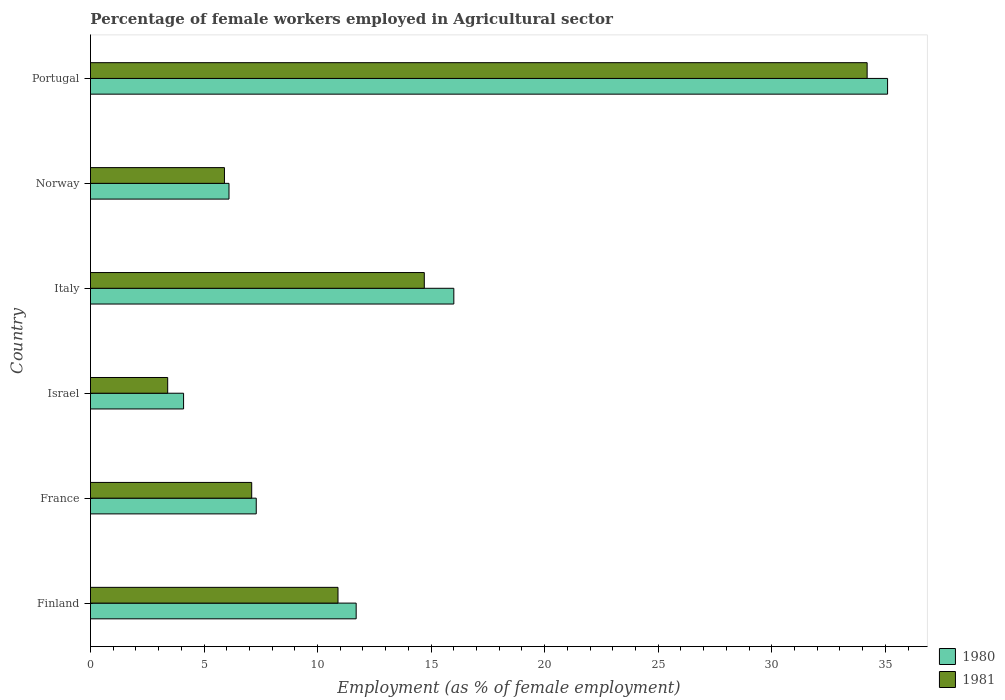Are the number of bars per tick equal to the number of legend labels?
Make the answer very short. Yes. How many bars are there on the 5th tick from the top?
Your answer should be very brief. 2. What is the label of the 4th group of bars from the top?
Make the answer very short. Israel. What is the percentage of females employed in Agricultural sector in 1981 in Norway?
Your response must be concise. 5.9. Across all countries, what is the maximum percentage of females employed in Agricultural sector in 1980?
Provide a short and direct response. 35.1. Across all countries, what is the minimum percentage of females employed in Agricultural sector in 1980?
Offer a terse response. 4.1. In which country was the percentage of females employed in Agricultural sector in 1980 maximum?
Offer a very short reply. Portugal. What is the total percentage of females employed in Agricultural sector in 1981 in the graph?
Provide a short and direct response. 76.2. What is the difference between the percentage of females employed in Agricultural sector in 1980 in Italy and that in Portugal?
Offer a terse response. -19.1. What is the difference between the percentage of females employed in Agricultural sector in 1981 in Israel and the percentage of females employed in Agricultural sector in 1980 in Norway?
Offer a very short reply. -2.7. What is the average percentage of females employed in Agricultural sector in 1981 per country?
Give a very brief answer. 12.7. What is the difference between the percentage of females employed in Agricultural sector in 1981 and percentage of females employed in Agricultural sector in 1980 in Italy?
Provide a succinct answer. -1.3. In how many countries, is the percentage of females employed in Agricultural sector in 1981 greater than 30 %?
Make the answer very short. 1. What is the ratio of the percentage of females employed in Agricultural sector in 1981 in Finland to that in Norway?
Provide a short and direct response. 1.85. Is the percentage of females employed in Agricultural sector in 1981 in France less than that in Portugal?
Your response must be concise. Yes. What is the difference between the highest and the second highest percentage of females employed in Agricultural sector in 1980?
Make the answer very short. 19.1. What is the difference between the highest and the lowest percentage of females employed in Agricultural sector in 1981?
Keep it short and to the point. 30.8. What does the 2nd bar from the top in Italy represents?
Provide a short and direct response. 1980. What does the 2nd bar from the bottom in Italy represents?
Ensure brevity in your answer.  1981. Are all the bars in the graph horizontal?
Offer a very short reply. Yes. What is the difference between two consecutive major ticks on the X-axis?
Provide a succinct answer. 5. Does the graph contain any zero values?
Provide a succinct answer. No. Does the graph contain grids?
Ensure brevity in your answer.  No. Where does the legend appear in the graph?
Your response must be concise. Bottom right. What is the title of the graph?
Offer a very short reply. Percentage of female workers employed in Agricultural sector. What is the label or title of the X-axis?
Make the answer very short. Employment (as % of female employment). What is the label or title of the Y-axis?
Provide a succinct answer. Country. What is the Employment (as % of female employment) of 1980 in Finland?
Ensure brevity in your answer.  11.7. What is the Employment (as % of female employment) in 1981 in Finland?
Provide a short and direct response. 10.9. What is the Employment (as % of female employment) in 1980 in France?
Offer a terse response. 7.3. What is the Employment (as % of female employment) in 1981 in France?
Your answer should be very brief. 7.1. What is the Employment (as % of female employment) of 1980 in Israel?
Offer a terse response. 4.1. What is the Employment (as % of female employment) in 1981 in Israel?
Give a very brief answer. 3.4. What is the Employment (as % of female employment) in 1980 in Italy?
Keep it short and to the point. 16. What is the Employment (as % of female employment) of 1981 in Italy?
Your answer should be compact. 14.7. What is the Employment (as % of female employment) in 1980 in Norway?
Make the answer very short. 6.1. What is the Employment (as % of female employment) in 1981 in Norway?
Your answer should be very brief. 5.9. What is the Employment (as % of female employment) in 1980 in Portugal?
Provide a succinct answer. 35.1. What is the Employment (as % of female employment) of 1981 in Portugal?
Provide a short and direct response. 34.2. Across all countries, what is the maximum Employment (as % of female employment) of 1980?
Your answer should be very brief. 35.1. Across all countries, what is the maximum Employment (as % of female employment) of 1981?
Provide a short and direct response. 34.2. Across all countries, what is the minimum Employment (as % of female employment) of 1980?
Provide a short and direct response. 4.1. Across all countries, what is the minimum Employment (as % of female employment) of 1981?
Offer a terse response. 3.4. What is the total Employment (as % of female employment) in 1980 in the graph?
Give a very brief answer. 80.3. What is the total Employment (as % of female employment) in 1981 in the graph?
Offer a terse response. 76.2. What is the difference between the Employment (as % of female employment) of 1980 in Finland and that in France?
Your answer should be compact. 4.4. What is the difference between the Employment (as % of female employment) in 1981 in Finland and that in Israel?
Offer a terse response. 7.5. What is the difference between the Employment (as % of female employment) of 1980 in Finland and that in Italy?
Offer a terse response. -4.3. What is the difference between the Employment (as % of female employment) of 1980 in Finland and that in Norway?
Your answer should be very brief. 5.6. What is the difference between the Employment (as % of female employment) of 1981 in Finland and that in Norway?
Make the answer very short. 5. What is the difference between the Employment (as % of female employment) of 1980 in Finland and that in Portugal?
Provide a succinct answer. -23.4. What is the difference between the Employment (as % of female employment) in 1981 in Finland and that in Portugal?
Offer a very short reply. -23.3. What is the difference between the Employment (as % of female employment) of 1981 in France and that in Israel?
Provide a short and direct response. 3.7. What is the difference between the Employment (as % of female employment) of 1980 in France and that in Italy?
Ensure brevity in your answer.  -8.7. What is the difference between the Employment (as % of female employment) in 1981 in France and that in Italy?
Keep it short and to the point. -7.6. What is the difference between the Employment (as % of female employment) in 1980 in France and that in Norway?
Offer a terse response. 1.2. What is the difference between the Employment (as % of female employment) in 1981 in France and that in Norway?
Your answer should be compact. 1.2. What is the difference between the Employment (as % of female employment) of 1980 in France and that in Portugal?
Your answer should be very brief. -27.8. What is the difference between the Employment (as % of female employment) in 1981 in France and that in Portugal?
Your response must be concise. -27.1. What is the difference between the Employment (as % of female employment) of 1980 in Israel and that in Italy?
Your answer should be compact. -11.9. What is the difference between the Employment (as % of female employment) of 1981 in Israel and that in Italy?
Your response must be concise. -11.3. What is the difference between the Employment (as % of female employment) of 1980 in Israel and that in Norway?
Make the answer very short. -2. What is the difference between the Employment (as % of female employment) in 1981 in Israel and that in Norway?
Ensure brevity in your answer.  -2.5. What is the difference between the Employment (as % of female employment) of 1980 in Israel and that in Portugal?
Offer a terse response. -31. What is the difference between the Employment (as % of female employment) of 1981 in Israel and that in Portugal?
Ensure brevity in your answer.  -30.8. What is the difference between the Employment (as % of female employment) of 1981 in Italy and that in Norway?
Provide a succinct answer. 8.8. What is the difference between the Employment (as % of female employment) of 1980 in Italy and that in Portugal?
Give a very brief answer. -19.1. What is the difference between the Employment (as % of female employment) of 1981 in Italy and that in Portugal?
Ensure brevity in your answer.  -19.5. What is the difference between the Employment (as % of female employment) of 1980 in Norway and that in Portugal?
Keep it short and to the point. -29. What is the difference between the Employment (as % of female employment) in 1981 in Norway and that in Portugal?
Give a very brief answer. -28.3. What is the difference between the Employment (as % of female employment) in 1980 in Finland and the Employment (as % of female employment) in 1981 in France?
Offer a very short reply. 4.6. What is the difference between the Employment (as % of female employment) of 1980 in Finland and the Employment (as % of female employment) of 1981 in Norway?
Offer a very short reply. 5.8. What is the difference between the Employment (as % of female employment) of 1980 in Finland and the Employment (as % of female employment) of 1981 in Portugal?
Your response must be concise. -22.5. What is the difference between the Employment (as % of female employment) of 1980 in France and the Employment (as % of female employment) of 1981 in Israel?
Your answer should be compact. 3.9. What is the difference between the Employment (as % of female employment) in 1980 in France and the Employment (as % of female employment) in 1981 in Norway?
Offer a terse response. 1.4. What is the difference between the Employment (as % of female employment) in 1980 in France and the Employment (as % of female employment) in 1981 in Portugal?
Your response must be concise. -26.9. What is the difference between the Employment (as % of female employment) of 1980 in Israel and the Employment (as % of female employment) of 1981 in Italy?
Provide a succinct answer. -10.6. What is the difference between the Employment (as % of female employment) of 1980 in Israel and the Employment (as % of female employment) of 1981 in Portugal?
Offer a terse response. -30.1. What is the difference between the Employment (as % of female employment) of 1980 in Italy and the Employment (as % of female employment) of 1981 in Portugal?
Your answer should be very brief. -18.2. What is the difference between the Employment (as % of female employment) in 1980 in Norway and the Employment (as % of female employment) in 1981 in Portugal?
Make the answer very short. -28.1. What is the average Employment (as % of female employment) of 1980 per country?
Your response must be concise. 13.38. What is the average Employment (as % of female employment) of 1981 per country?
Offer a terse response. 12.7. What is the difference between the Employment (as % of female employment) of 1980 and Employment (as % of female employment) of 1981 in Finland?
Your answer should be compact. 0.8. What is the difference between the Employment (as % of female employment) in 1980 and Employment (as % of female employment) in 1981 in France?
Offer a very short reply. 0.2. What is the difference between the Employment (as % of female employment) in 1980 and Employment (as % of female employment) in 1981 in Israel?
Provide a short and direct response. 0.7. What is the difference between the Employment (as % of female employment) in 1980 and Employment (as % of female employment) in 1981 in Norway?
Provide a short and direct response. 0.2. What is the ratio of the Employment (as % of female employment) in 1980 in Finland to that in France?
Ensure brevity in your answer.  1.6. What is the ratio of the Employment (as % of female employment) of 1981 in Finland to that in France?
Give a very brief answer. 1.54. What is the ratio of the Employment (as % of female employment) of 1980 in Finland to that in Israel?
Keep it short and to the point. 2.85. What is the ratio of the Employment (as % of female employment) of 1981 in Finland to that in Israel?
Ensure brevity in your answer.  3.21. What is the ratio of the Employment (as % of female employment) in 1980 in Finland to that in Italy?
Your answer should be compact. 0.73. What is the ratio of the Employment (as % of female employment) in 1981 in Finland to that in Italy?
Offer a very short reply. 0.74. What is the ratio of the Employment (as % of female employment) in 1980 in Finland to that in Norway?
Provide a short and direct response. 1.92. What is the ratio of the Employment (as % of female employment) of 1981 in Finland to that in Norway?
Your response must be concise. 1.85. What is the ratio of the Employment (as % of female employment) in 1981 in Finland to that in Portugal?
Your response must be concise. 0.32. What is the ratio of the Employment (as % of female employment) of 1980 in France to that in Israel?
Your response must be concise. 1.78. What is the ratio of the Employment (as % of female employment) in 1981 in France to that in Israel?
Provide a short and direct response. 2.09. What is the ratio of the Employment (as % of female employment) in 1980 in France to that in Italy?
Offer a terse response. 0.46. What is the ratio of the Employment (as % of female employment) in 1981 in France to that in Italy?
Provide a succinct answer. 0.48. What is the ratio of the Employment (as % of female employment) in 1980 in France to that in Norway?
Offer a very short reply. 1.2. What is the ratio of the Employment (as % of female employment) of 1981 in France to that in Norway?
Provide a short and direct response. 1.2. What is the ratio of the Employment (as % of female employment) of 1980 in France to that in Portugal?
Your response must be concise. 0.21. What is the ratio of the Employment (as % of female employment) in 1981 in France to that in Portugal?
Offer a very short reply. 0.21. What is the ratio of the Employment (as % of female employment) in 1980 in Israel to that in Italy?
Make the answer very short. 0.26. What is the ratio of the Employment (as % of female employment) in 1981 in Israel to that in Italy?
Ensure brevity in your answer.  0.23. What is the ratio of the Employment (as % of female employment) of 1980 in Israel to that in Norway?
Offer a terse response. 0.67. What is the ratio of the Employment (as % of female employment) of 1981 in Israel to that in Norway?
Provide a short and direct response. 0.58. What is the ratio of the Employment (as % of female employment) of 1980 in Israel to that in Portugal?
Offer a very short reply. 0.12. What is the ratio of the Employment (as % of female employment) of 1981 in Israel to that in Portugal?
Your response must be concise. 0.1. What is the ratio of the Employment (as % of female employment) in 1980 in Italy to that in Norway?
Your answer should be very brief. 2.62. What is the ratio of the Employment (as % of female employment) of 1981 in Italy to that in Norway?
Give a very brief answer. 2.49. What is the ratio of the Employment (as % of female employment) in 1980 in Italy to that in Portugal?
Provide a succinct answer. 0.46. What is the ratio of the Employment (as % of female employment) in 1981 in Italy to that in Portugal?
Offer a very short reply. 0.43. What is the ratio of the Employment (as % of female employment) of 1980 in Norway to that in Portugal?
Ensure brevity in your answer.  0.17. What is the ratio of the Employment (as % of female employment) in 1981 in Norway to that in Portugal?
Offer a very short reply. 0.17. What is the difference between the highest and the lowest Employment (as % of female employment) in 1981?
Offer a very short reply. 30.8. 